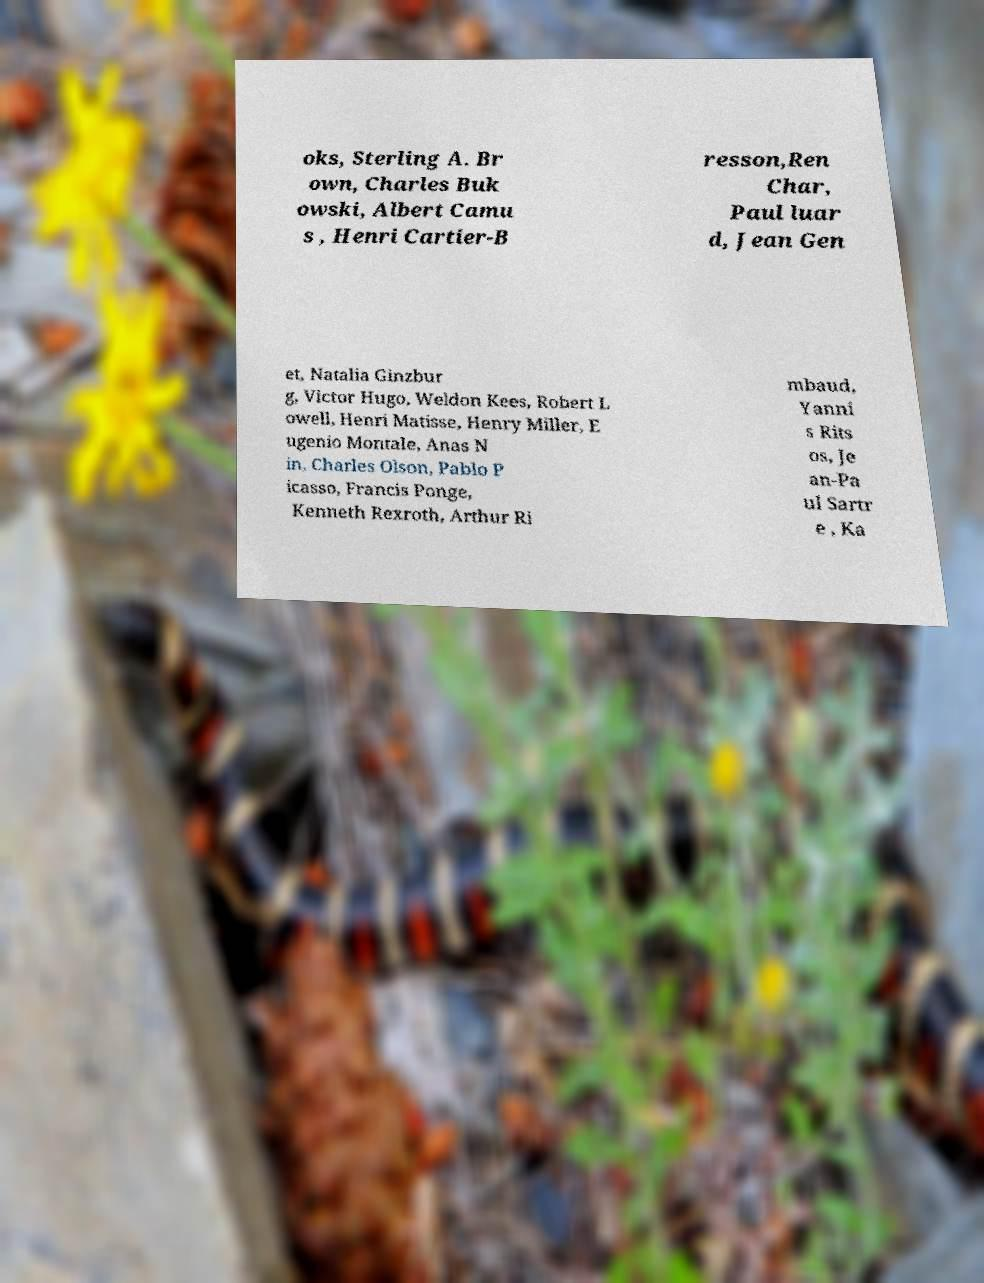Could you extract and type out the text from this image? oks, Sterling A. Br own, Charles Buk owski, Albert Camu s , Henri Cartier-B resson,Ren Char, Paul luar d, Jean Gen et, Natalia Ginzbur g, Victor Hugo, Weldon Kees, Robert L owell, Henri Matisse, Henry Miller, E ugenio Montale, Anas N in, Charles Olson, Pablo P icasso, Francis Ponge, Kenneth Rexroth, Arthur Ri mbaud, Yanni s Rits os, Je an-Pa ul Sartr e , Ka 